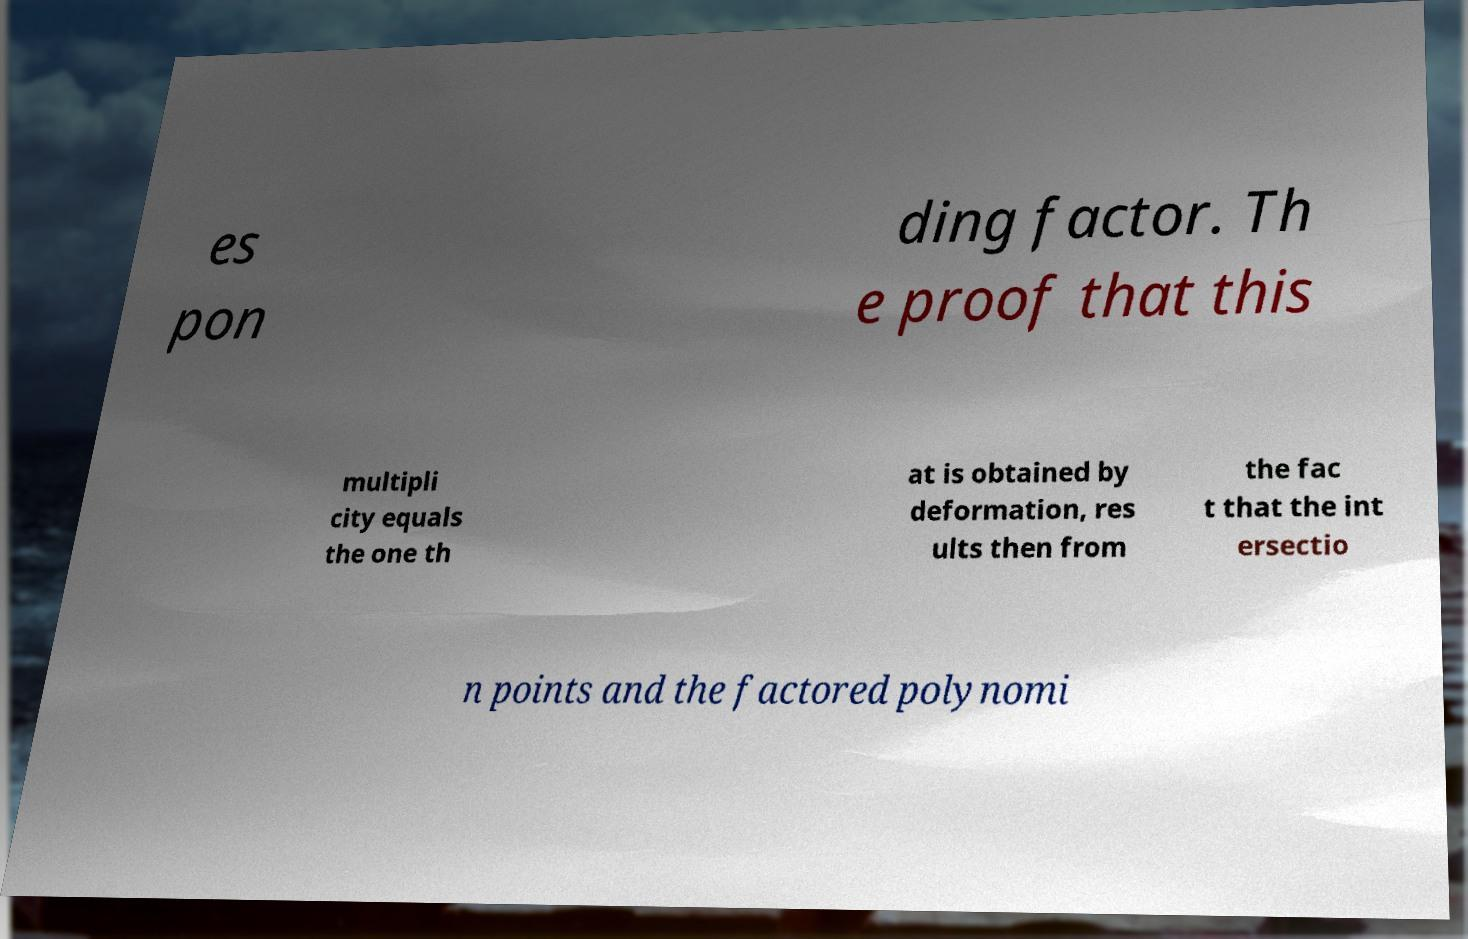I need the written content from this picture converted into text. Can you do that? es pon ding factor. Th e proof that this multipli city equals the one th at is obtained by deformation, res ults then from the fac t that the int ersectio n points and the factored polynomi 